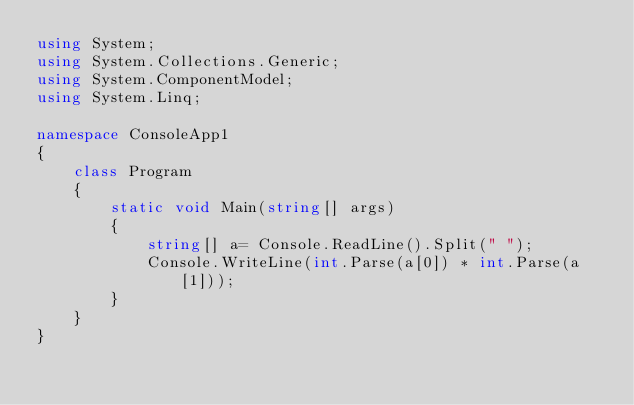<code> <loc_0><loc_0><loc_500><loc_500><_C#_>using System;
using System.Collections.Generic;
using System.ComponentModel;
using System.Linq;

namespace ConsoleApp1
{
    class Program
    {
        static void Main(string[] args)
        {
            string[] a= Console.ReadLine().Split(" ");
            Console.WriteLine(int.Parse(a[0]) * int.Parse(a[1]));
        }
    }
}</code> 